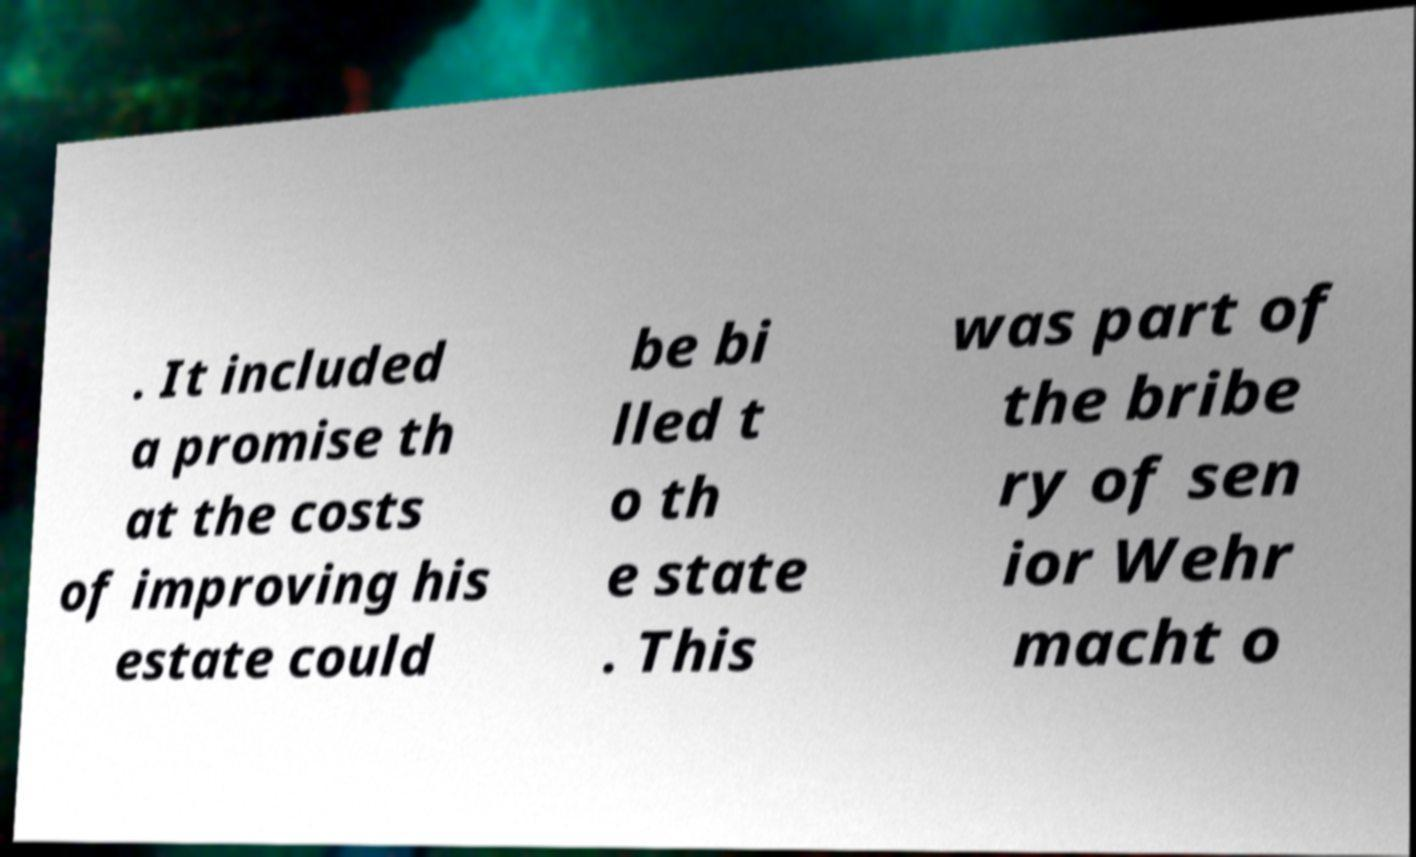Could you extract and type out the text from this image? . It included a promise th at the costs of improving his estate could be bi lled t o th e state . This was part of the bribe ry of sen ior Wehr macht o 